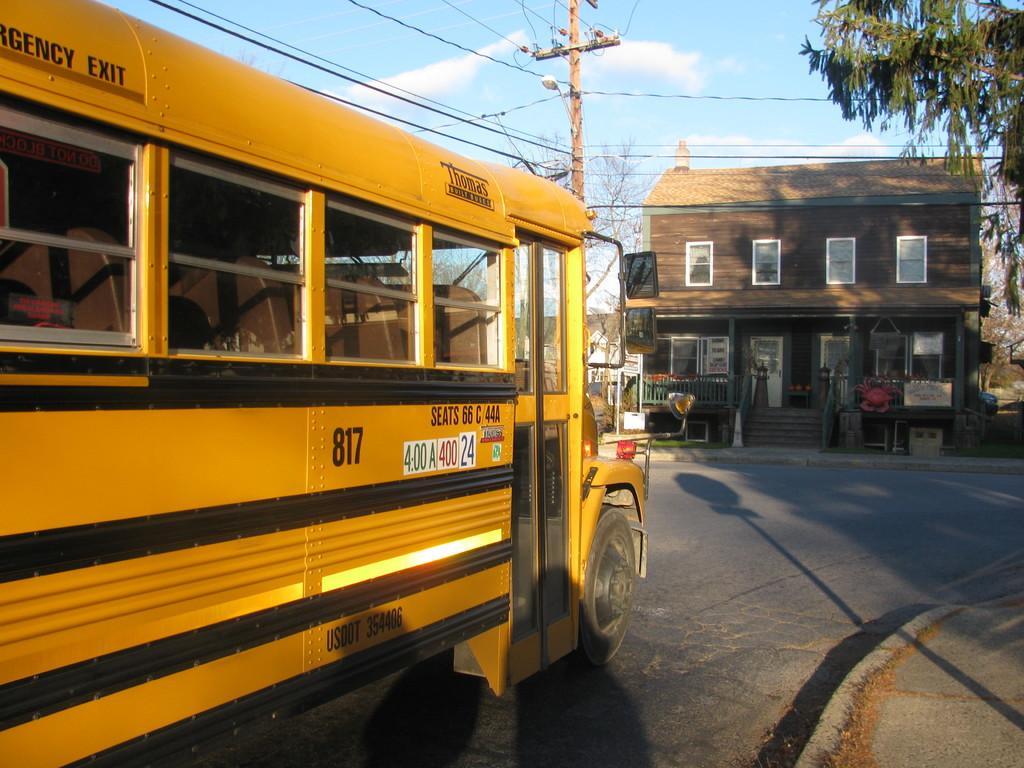Please provide a concise description of this image. In this image, we can see a bus on the road. There is a street pole at the top of the image. There is a shelter house beside the road. There is a branch in the top right of the image. 